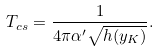Convert formula to latex. <formula><loc_0><loc_0><loc_500><loc_500>T _ { c s } = \frac { 1 } { 4 \pi \alpha ^ { \prime } \sqrt { h ( y _ { K } ) } } .</formula> 